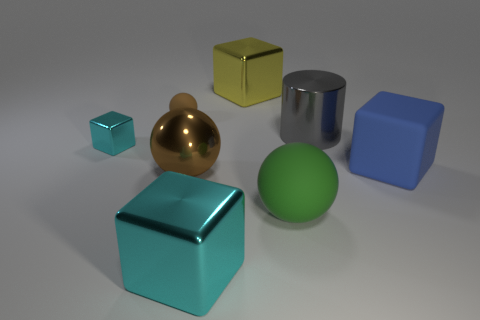Add 2 green spheres. How many objects exist? 10 Subtract all cylinders. How many objects are left? 7 Subtract 1 brown balls. How many objects are left? 7 Subtract all large blocks. Subtract all big brown metallic things. How many objects are left? 4 Add 3 tiny balls. How many tiny balls are left? 4 Add 5 small purple blocks. How many small purple blocks exist? 5 